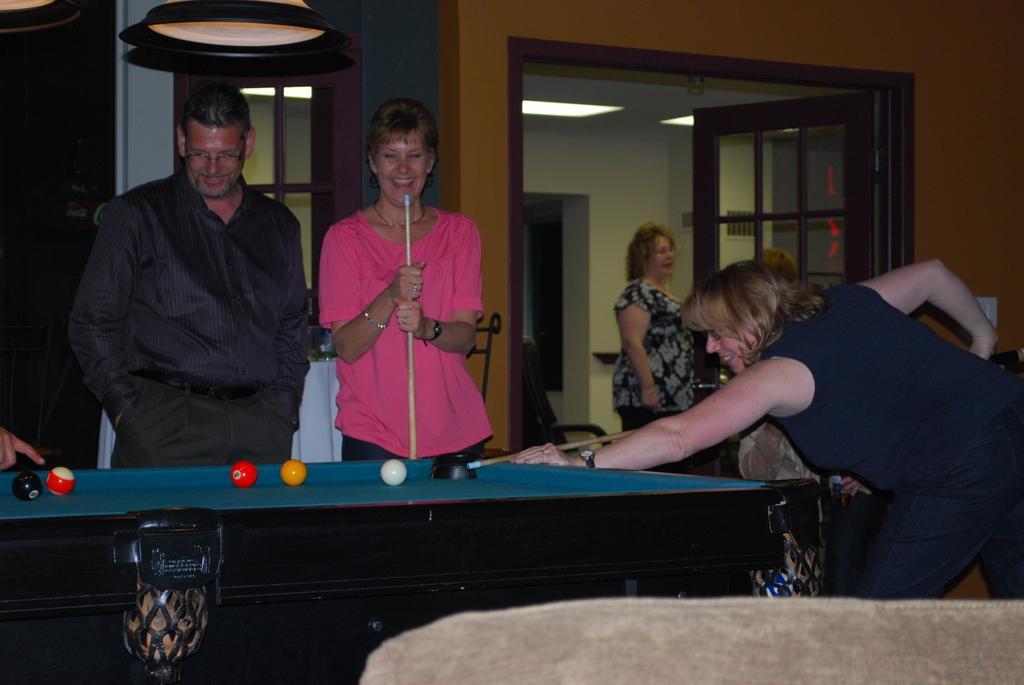How would you summarize this image in a sentence or two? In this image we can see three people standing beside the snooker table containing some balls on it. In that two women are holding the sticks. We can also see a person sitting beside the table. We can also see some people standing, a door, window, lamps and some ceiling lights to a roof. 